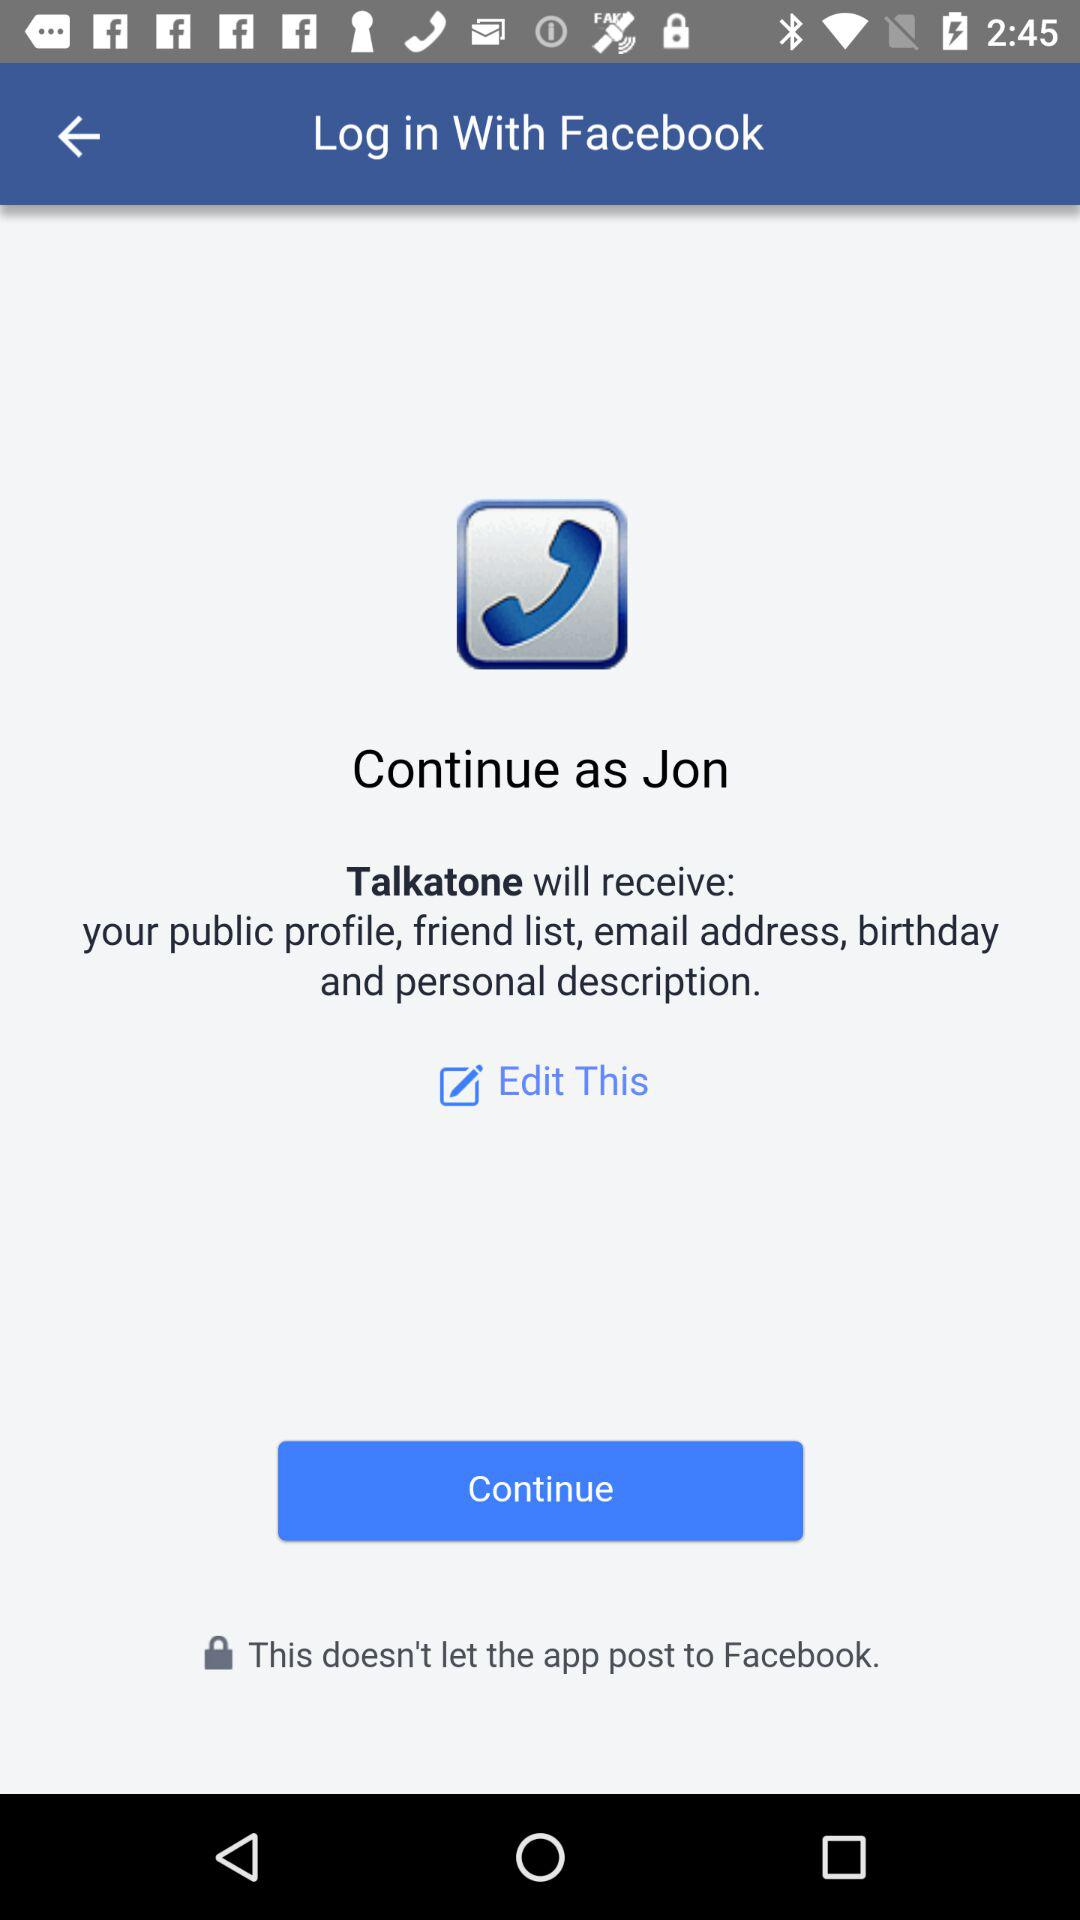Through what application can a user log in with? A user can log in with Facebook. 